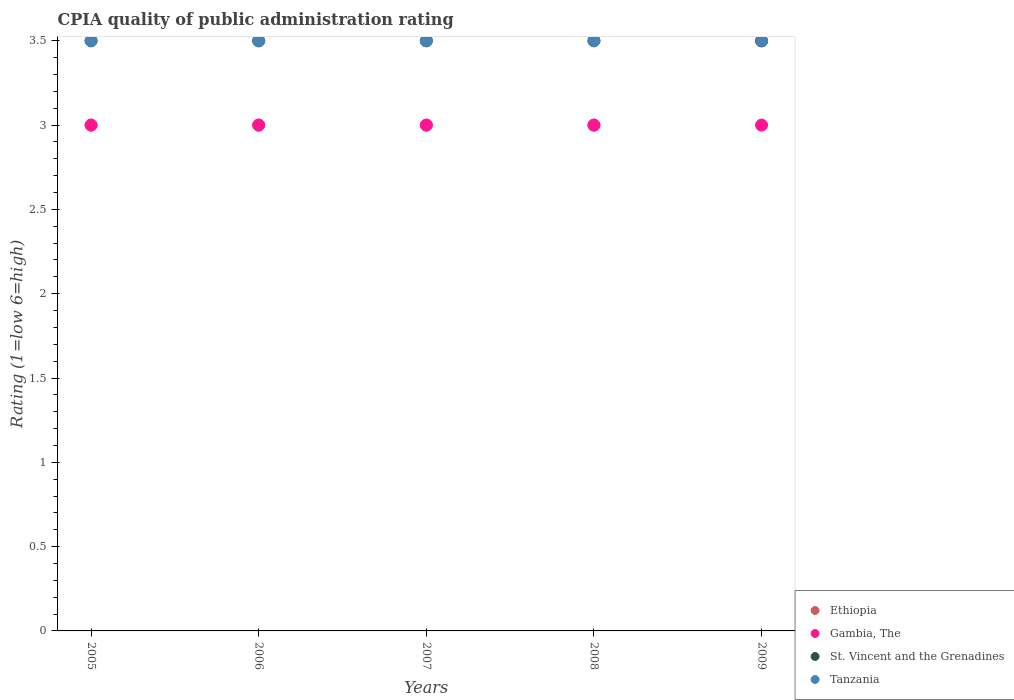Across all years, what is the maximum CPIA rating in Tanzania?
Your answer should be very brief. 3.5. Across all years, what is the minimum CPIA rating in Ethiopia?
Provide a short and direct response. 3. In which year was the CPIA rating in Ethiopia maximum?
Your response must be concise. 2009. What is the total CPIA rating in Tanzania in the graph?
Keep it short and to the point. 17.5. What is the difference between the CPIA rating in St. Vincent and the Grenadines in 2007 and the CPIA rating in Gambia, The in 2009?
Offer a very short reply. 0.5. In how many years, is the CPIA rating in St. Vincent and the Grenadines greater than 2.4?
Make the answer very short. 5. What is the ratio of the CPIA rating in St. Vincent and the Grenadines in 2007 to that in 2009?
Your response must be concise. 1. Is the difference between the CPIA rating in Tanzania in 2005 and 2006 greater than the difference between the CPIA rating in Ethiopia in 2005 and 2006?
Provide a succinct answer. No. Is the sum of the CPIA rating in St. Vincent and the Grenadines in 2006 and 2008 greater than the maximum CPIA rating in Ethiopia across all years?
Offer a terse response. Yes. Is the CPIA rating in Tanzania strictly greater than the CPIA rating in St. Vincent and the Grenadines over the years?
Provide a succinct answer. No. How many dotlines are there?
Give a very brief answer. 4. How many years are there in the graph?
Your answer should be compact. 5. Are the values on the major ticks of Y-axis written in scientific E-notation?
Make the answer very short. No. Does the graph contain any zero values?
Your answer should be compact. No. How many legend labels are there?
Give a very brief answer. 4. How are the legend labels stacked?
Provide a short and direct response. Vertical. What is the title of the graph?
Provide a short and direct response. CPIA quality of public administration rating. Does "Faeroe Islands" appear as one of the legend labels in the graph?
Provide a short and direct response. No. What is the label or title of the X-axis?
Keep it short and to the point. Years. What is the Rating (1=low 6=high) of Ethiopia in 2005?
Provide a succinct answer. 3. What is the Rating (1=low 6=high) of Gambia, The in 2005?
Offer a very short reply. 3. What is the Rating (1=low 6=high) of St. Vincent and the Grenadines in 2005?
Provide a short and direct response. 3.5. What is the Rating (1=low 6=high) of Ethiopia in 2006?
Ensure brevity in your answer.  3. What is the Rating (1=low 6=high) in Gambia, The in 2006?
Provide a succinct answer. 3. What is the Rating (1=low 6=high) of St. Vincent and the Grenadines in 2006?
Offer a very short reply. 3.5. What is the Rating (1=low 6=high) of Gambia, The in 2007?
Provide a succinct answer. 3. What is the Rating (1=low 6=high) in Tanzania in 2007?
Offer a very short reply. 3.5. What is the Rating (1=low 6=high) in St. Vincent and the Grenadines in 2008?
Give a very brief answer. 3.5. What is the Rating (1=low 6=high) in Gambia, The in 2009?
Your response must be concise. 3. What is the Rating (1=low 6=high) in St. Vincent and the Grenadines in 2009?
Make the answer very short. 3.5. Across all years, what is the maximum Rating (1=low 6=high) of St. Vincent and the Grenadines?
Provide a succinct answer. 3.5. Across all years, what is the minimum Rating (1=low 6=high) in Tanzania?
Provide a succinct answer. 3.5. What is the total Rating (1=low 6=high) in Gambia, The in the graph?
Make the answer very short. 15. What is the total Rating (1=low 6=high) in Tanzania in the graph?
Offer a terse response. 17.5. What is the difference between the Rating (1=low 6=high) of Tanzania in 2005 and that in 2006?
Ensure brevity in your answer.  0. What is the difference between the Rating (1=low 6=high) of St. Vincent and the Grenadines in 2005 and that in 2007?
Provide a succinct answer. 0. What is the difference between the Rating (1=low 6=high) of Tanzania in 2005 and that in 2007?
Offer a very short reply. 0. What is the difference between the Rating (1=low 6=high) of St. Vincent and the Grenadines in 2005 and that in 2009?
Your response must be concise. 0. What is the difference between the Rating (1=low 6=high) in Tanzania in 2005 and that in 2009?
Offer a very short reply. 0. What is the difference between the Rating (1=low 6=high) in Ethiopia in 2006 and that in 2007?
Make the answer very short. 0. What is the difference between the Rating (1=low 6=high) of Tanzania in 2006 and that in 2007?
Provide a short and direct response. 0. What is the difference between the Rating (1=low 6=high) of Ethiopia in 2006 and that in 2008?
Your answer should be compact. 0. What is the difference between the Rating (1=low 6=high) in Tanzania in 2006 and that in 2008?
Your answer should be compact. 0. What is the difference between the Rating (1=low 6=high) of Ethiopia in 2006 and that in 2009?
Your answer should be compact. -0.5. What is the difference between the Rating (1=low 6=high) of Gambia, The in 2006 and that in 2009?
Offer a terse response. 0. What is the difference between the Rating (1=low 6=high) of Gambia, The in 2007 and that in 2008?
Provide a succinct answer. 0. What is the difference between the Rating (1=low 6=high) in St. Vincent and the Grenadines in 2007 and that in 2008?
Your answer should be compact. 0. What is the difference between the Rating (1=low 6=high) in Gambia, The in 2007 and that in 2009?
Give a very brief answer. 0. What is the difference between the Rating (1=low 6=high) of Gambia, The in 2008 and that in 2009?
Give a very brief answer. 0. What is the difference between the Rating (1=low 6=high) of Tanzania in 2008 and that in 2009?
Offer a very short reply. 0. What is the difference between the Rating (1=low 6=high) of Ethiopia in 2005 and the Rating (1=low 6=high) of St. Vincent and the Grenadines in 2006?
Offer a terse response. -0.5. What is the difference between the Rating (1=low 6=high) in Gambia, The in 2005 and the Rating (1=low 6=high) in St. Vincent and the Grenadines in 2006?
Keep it short and to the point. -0.5. What is the difference between the Rating (1=low 6=high) of Ethiopia in 2005 and the Rating (1=low 6=high) of St. Vincent and the Grenadines in 2007?
Provide a short and direct response. -0.5. What is the difference between the Rating (1=low 6=high) of Ethiopia in 2005 and the Rating (1=low 6=high) of Tanzania in 2007?
Keep it short and to the point. -0.5. What is the difference between the Rating (1=low 6=high) in Gambia, The in 2005 and the Rating (1=low 6=high) in Tanzania in 2007?
Offer a very short reply. -0.5. What is the difference between the Rating (1=low 6=high) of St. Vincent and the Grenadines in 2005 and the Rating (1=low 6=high) of Tanzania in 2007?
Your answer should be very brief. 0. What is the difference between the Rating (1=low 6=high) of Ethiopia in 2005 and the Rating (1=low 6=high) of Gambia, The in 2008?
Offer a very short reply. 0. What is the difference between the Rating (1=low 6=high) in Ethiopia in 2005 and the Rating (1=low 6=high) in St. Vincent and the Grenadines in 2008?
Offer a terse response. -0.5. What is the difference between the Rating (1=low 6=high) of Gambia, The in 2005 and the Rating (1=low 6=high) of Tanzania in 2008?
Your answer should be very brief. -0.5. What is the difference between the Rating (1=low 6=high) in Ethiopia in 2005 and the Rating (1=low 6=high) in St. Vincent and the Grenadines in 2009?
Offer a very short reply. -0.5. What is the difference between the Rating (1=low 6=high) of Ethiopia in 2005 and the Rating (1=low 6=high) of Tanzania in 2009?
Your answer should be compact. -0.5. What is the difference between the Rating (1=low 6=high) of Gambia, The in 2005 and the Rating (1=low 6=high) of Tanzania in 2009?
Ensure brevity in your answer.  -0.5. What is the difference between the Rating (1=low 6=high) in St. Vincent and the Grenadines in 2005 and the Rating (1=low 6=high) in Tanzania in 2009?
Ensure brevity in your answer.  0. What is the difference between the Rating (1=low 6=high) in Ethiopia in 2006 and the Rating (1=low 6=high) in St. Vincent and the Grenadines in 2007?
Offer a very short reply. -0.5. What is the difference between the Rating (1=low 6=high) in Gambia, The in 2006 and the Rating (1=low 6=high) in St. Vincent and the Grenadines in 2007?
Offer a terse response. -0.5. What is the difference between the Rating (1=low 6=high) of Gambia, The in 2006 and the Rating (1=low 6=high) of Tanzania in 2007?
Give a very brief answer. -0.5. What is the difference between the Rating (1=low 6=high) in Ethiopia in 2006 and the Rating (1=low 6=high) in Gambia, The in 2008?
Offer a terse response. 0. What is the difference between the Rating (1=low 6=high) of Gambia, The in 2006 and the Rating (1=low 6=high) of St. Vincent and the Grenadines in 2008?
Your answer should be compact. -0.5. What is the difference between the Rating (1=low 6=high) in Gambia, The in 2006 and the Rating (1=low 6=high) in Tanzania in 2008?
Your answer should be compact. -0.5. What is the difference between the Rating (1=low 6=high) of St. Vincent and the Grenadines in 2006 and the Rating (1=low 6=high) of Tanzania in 2008?
Your response must be concise. 0. What is the difference between the Rating (1=low 6=high) in Ethiopia in 2006 and the Rating (1=low 6=high) in Gambia, The in 2009?
Provide a succinct answer. 0. What is the difference between the Rating (1=low 6=high) of Ethiopia in 2006 and the Rating (1=low 6=high) of St. Vincent and the Grenadines in 2009?
Provide a succinct answer. -0.5. What is the difference between the Rating (1=low 6=high) in St. Vincent and the Grenadines in 2006 and the Rating (1=low 6=high) in Tanzania in 2009?
Offer a very short reply. 0. What is the difference between the Rating (1=low 6=high) of Ethiopia in 2007 and the Rating (1=low 6=high) of Tanzania in 2008?
Offer a very short reply. -0.5. What is the difference between the Rating (1=low 6=high) in Gambia, The in 2007 and the Rating (1=low 6=high) in St. Vincent and the Grenadines in 2008?
Your response must be concise. -0.5. What is the difference between the Rating (1=low 6=high) of Gambia, The in 2007 and the Rating (1=low 6=high) of Tanzania in 2008?
Your answer should be compact. -0.5. What is the difference between the Rating (1=low 6=high) in St. Vincent and the Grenadines in 2007 and the Rating (1=low 6=high) in Tanzania in 2008?
Keep it short and to the point. 0. What is the difference between the Rating (1=low 6=high) in Ethiopia in 2007 and the Rating (1=low 6=high) in Gambia, The in 2009?
Your answer should be very brief. 0. What is the difference between the Rating (1=low 6=high) of Ethiopia in 2007 and the Rating (1=low 6=high) of Tanzania in 2009?
Keep it short and to the point. -0.5. What is the difference between the Rating (1=low 6=high) of Gambia, The in 2007 and the Rating (1=low 6=high) of St. Vincent and the Grenadines in 2009?
Your answer should be compact. -0.5. What is the difference between the Rating (1=low 6=high) in Gambia, The in 2007 and the Rating (1=low 6=high) in Tanzania in 2009?
Your answer should be very brief. -0.5. What is the difference between the Rating (1=low 6=high) of St. Vincent and the Grenadines in 2007 and the Rating (1=low 6=high) of Tanzania in 2009?
Provide a succinct answer. 0. What is the difference between the Rating (1=low 6=high) of Gambia, The in 2008 and the Rating (1=low 6=high) of Tanzania in 2009?
Provide a short and direct response. -0.5. What is the average Rating (1=low 6=high) in Gambia, The per year?
Your answer should be very brief. 3. In the year 2005, what is the difference between the Rating (1=low 6=high) of Ethiopia and Rating (1=low 6=high) of St. Vincent and the Grenadines?
Ensure brevity in your answer.  -0.5. In the year 2005, what is the difference between the Rating (1=low 6=high) of Ethiopia and Rating (1=low 6=high) of Tanzania?
Provide a short and direct response. -0.5. In the year 2006, what is the difference between the Rating (1=low 6=high) in Ethiopia and Rating (1=low 6=high) in Gambia, The?
Your answer should be compact. 0. In the year 2006, what is the difference between the Rating (1=low 6=high) of Ethiopia and Rating (1=low 6=high) of Tanzania?
Give a very brief answer. -0.5. In the year 2006, what is the difference between the Rating (1=low 6=high) of Gambia, The and Rating (1=low 6=high) of St. Vincent and the Grenadines?
Give a very brief answer. -0.5. In the year 2006, what is the difference between the Rating (1=low 6=high) in Gambia, The and Rating (1=low 6=high) in Tanzania?
Ensure brevity in your answer.  -0.5. In the year 2007, what is the difference between the Rating (1=low 6=high) in Gambia, The and Rating (1=low 6=high) in Tanzania?
Ensure brevity in your answer.  -0.5. In the year 2008, what is the difference between the Rating (1=low 6=high) in Gambia, The and Rating (1=low 6=high) in Tanzania?
Offer a terse response. -0.5. In the year 2008, what is the difference between the Rating (1=low 6=high) of St. Vincent and the Grenadines and Rating (1=low 6=high) of Tanzania?
Make the answer very short. 0. In the year 2009, what is the difference between the Rating (1=low 6=high) in Ethiopia and Rating (1=low 6=high) in Gambia, The?
Provide a succinct answer. 0.5. In the year 2009, what is the difference between the Rating (1=low 6=high) of Gambia, The and Rating (1=low 6=high) of St. Vincent and the Grenadines?
Keep it short and to the point. -0.5. In the year 2009, what is the difference between the Rating (1=low 6=high) in St. Vincent and the Grenadines and Rating (1=low 6=high) in Tanzania?
Offer a very short reply. 0. What is the ratio of the Rating (1=low 6=high) of Ethiopia in 2005 to that in 2006?
Your answer should be compact. 1. What is the ratio of the Rating (1=low 6=high) of Gambia, The in 2005 to that in 2006?
Give a very brief answer. 1. What is the ratio of the Rating (1=low 6=high) of St. Vincent and the Grenadines in 2005 to that in 2006?
Keep it short and to the point. 1. What is the ratio of the Rating (1=low 6=high) in Tanzania in 2005 to that in 2006?
Provide a succinct answer. 1. What is the ratio of the Rating (1=low 6=high) of St. Vincent and the Grenadines in 2005 to that in 2007?
Make the answer very short. 1. What is the ratio of the Rating (1=low 6=high) in Tanzania in 2005 to that in 2007?
Your answer should be very brief. 1. What is the ratio of the Rating (1=low 6=high) of Ethiopia in 2005 to that in 2008?
Ensure brevity in your answer.  1. What is the ratio of the Rating (1=low 6=high) of Gambia, The in 2005 to that in 2008?
Ensure brevity in your answer.  1. What is the ratio of the Rating (1=low 6=high) in St. Vincent and the Grenadines in 2005 to that in 2008?
Provide a short and direct response. 1. What is the ratio of the Rating (1=low 6=high) in Tanzania in 2005 to that in 2008?
Your answer should be compact. 1. What is the ratio of the Rating (1=low 6=high) of Ethiopia in 2005 to that in 2009?
Offer a very short reply. 0.86. What is the ratio of the Rating (1=low 6=high) of Gambia, The in 2005 to that in 2009?
Offer a very short reply. 1. What is the ratio of the Rating (1=low 6=high) of St. Vincent and the Grenadines in 2005 to that in 2009?
Give a very brief answer. 1. What is the ratio of the Rating (1=low 6=high) in Tanzania in 2005 to that in 2009?
Offer a very short reply. 1. What is the ratio of the Rating (1=low 6=high) in Ethiopia in 2006 to that in 2007?
Provide a succinct answer. 1. What is the ratio of the Rating (1=low 6=high) in Ethiopia in 2006 to that in 2008?
Provide a succinct answer. 1. What is the ratio of the Rating (1=low 6=high) in St. Vincent and the Grenadines in 2006 to that in 2009?
Your response must be concise. 1. What is the ratio of the Rating (1=low 6=high) of Ethiopia in 2007 to that in 2008?
Keep it short and to the point. 1. What is the ratio of the Rating (1=low 6=high) in Gambia, The in 2007 to that in 2008?
Offer a terse response. 1. What is the ratio of the Rating (1=low 6=high) in Tanzania in 2007 to that in 2008?
Keep it short and to the point. 1. What is the ratio of the Rating (1=low 6=high) of Ethiopia in 2007 to that in 2009?
Provide a succinct answer. 0.86. What is the ratio of the Rating (1=low 6=high) in Tanzania in 2007 to that in 2009?
Your answer should be very brief. 1. What is the ratio of the Rating (1=low 6=high) of Gambia, The in 2008 to that in 2009?
Provide a short and direct response. 1. What is the difference between the highest and the second highest Rating (1=low 6=high) of Gambia, The?
Provide a short and direct response. 0. What is the difference between the highest and the second highest Rating (1=low 6=high) in Tanzania?
Your answer should be compact. 0. What is the difference between the highest and the lowest Rating (1=low 6=high) of Gambia, The?
Your answer should be very brief. 0. What is the difference between the highest and the lowest Rating (1=low 6=high) of St. Vincent and the Grenadines?
Your answer should be very brief. 0. 